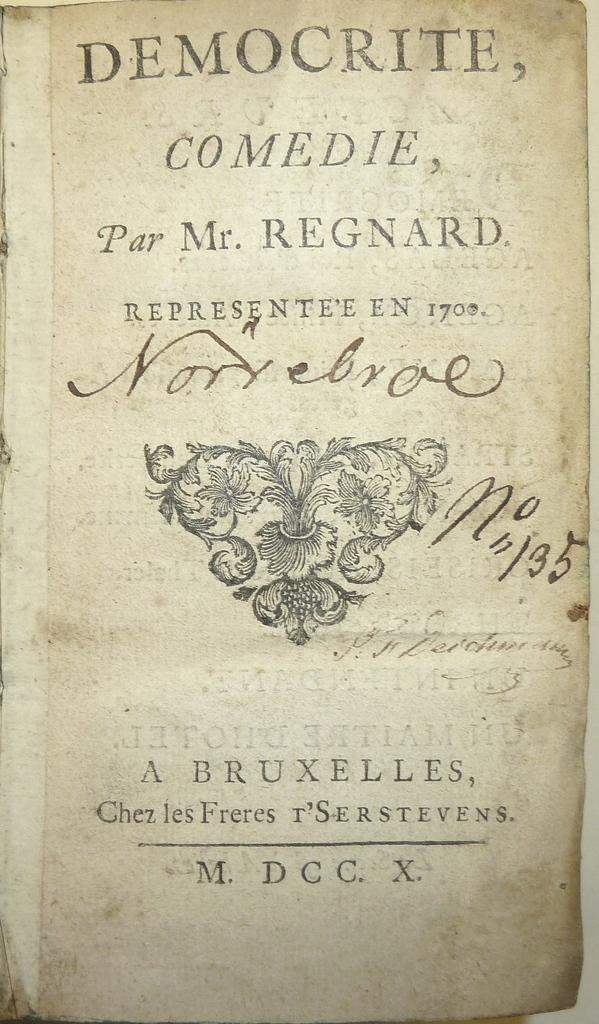<image>
Give a short and clear explanation of the subsequent image. An antique copy of the book Democrite is open to the Title page. 